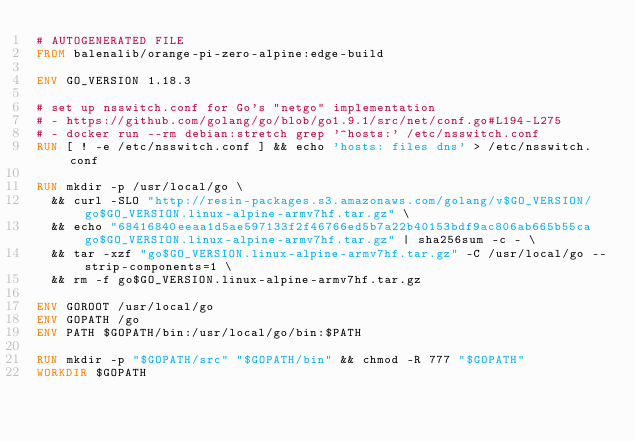<code> <loc_0><loc_0><loc_500><loc_500><_Dockerfile_># AUTOGENERATED FILE
FROM balenalib/orange-pi-zero-alpine:edge-build

ENV GO_VERSION 1.18.3

# set up nsswitch.conf for Go's "netgo" implementation
# - https://github.com/golang/go/blob/go1.9.1/src/net/conf.go#L194-L275
# - docker run --rm debian:stretch grep '^hosts:' /etc/nsswitch.conf
RUN [ ! -e /etc/nsswitch.conf ] && echo 'hosts: files dns' > /etc/nsswitch.conf

RUN mkdir -p /usr/local/go \
	&& curl -SLO "http://resin-packages.s3.amazonaws.com/golang/v$GO_VERSION/go$GO_VERSION.linux-alpine-armv7hf.tar.gz" \
	&& echo "68416840eeaa1d5ae597133f2f46766ed5b7a22b40153bdf9ac806ab665b55ca  go$GO_VERSION.linux-alpine-armv7hf.tar.gz" | sha256sum -c - \
	&& tar -xzf "go$GO_VERSION.linux-alpine-armv7hf.tar.gz" -C /usr/local/go --strip-components=1 \
	&& rm -f go$GO_VERSION.linux-alpine-armv7hf.tar.gz

ENV GOROOT /usr/local/go
ENV GOPATH /go
ENV PATH $GOPATH/bin:/usr/local/go/bin:$PATH

RUN mkdir -p "$GOPATH/src" "$GOPATH/bin" && chmod -R 777 "$GOPATH"
WORKDIR $GOPATH
</code> 